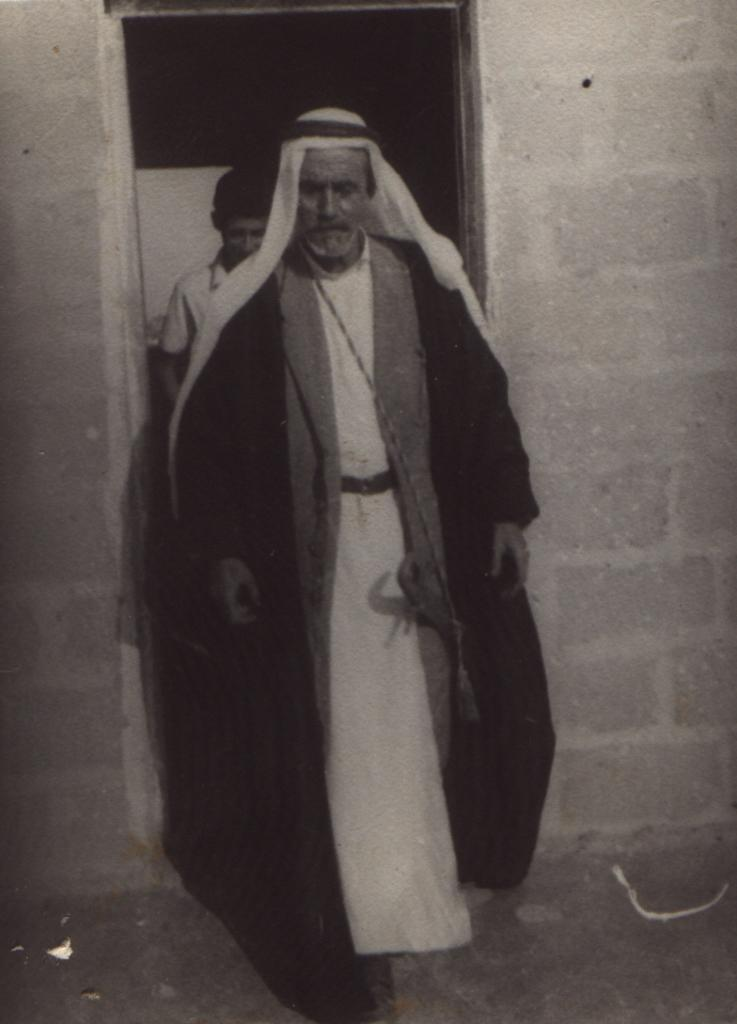What is the color scheme of the image? The image is black and white. What is the person in the foreground wearing? The person is wearing a coat and a kurta, and also has a head turban. Can you describe the background of the image? There is another person in the background of the image, and there is also a wall visible. How many geese are flying over the wall in the background of the image? There are no geese present in the image; it only features a person and a wall in the background. Can you describe the kick of the person in the image? There is no kick being performed by the person in the image; they are simply standing with a coat, kurta, and head turban. 